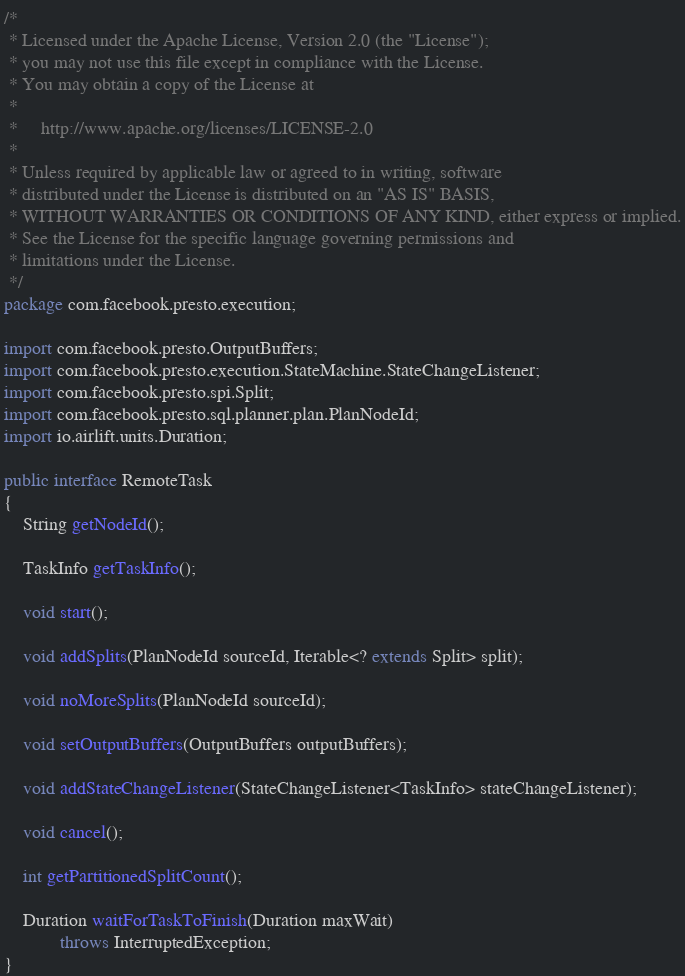Convert code to text. <code><loc_0><loc_0><loc_500><loc_500><_Java_>/*
 * Licensed under the Apache License, Version 2.0 (the "License");
 * you may not use this file except in compliance with the License.
 * You may obtain a copy of the License at
 *
 *     http://www.apache.org/licenses/LICENSE-2.0
 *
 * Unless required by applicable law or agreed to in writing, software
 * distributed under the License is distributed on an "AS IS" BASIS,
 * WITHOUT WARRANTIES OR CONDITIONS OF ANY KIND, either express or implied.
 * See the License for the specific language governing permissions and
 * limitations under the License.
 */
package com.facebook.presto.execution;

import com.facebook.presto.OutputBuffers;
import com.facebook.presto.execution.StateMachine.StateChangeListener;
import com.facebook.presto.spi.Split;
import com.facebook.presto.sql.planner.plan.PlanNodeId;
import io.airlift.units.Duration;

public interface RemoteTask
{
    String getNodeId();

    TaskInfo getTaskInfo();

    void start();

    void addSplits(PlanNodeId sourceId, Iterable<? extends Split> split);

    void noMoreSplits(PlanNodeId sourceId);

    void setOutputBuffers(OutputBuffers outputBuffers);

    void addStateChangeListener(StateChangeListener<TaskInfo> stateChangeListener);

    void cancel();

    int getPartitionedSplitCount();

    Duration waitForTaskToFinish(Duration maxWait)
            throws InterruptedException;
}
</code> 